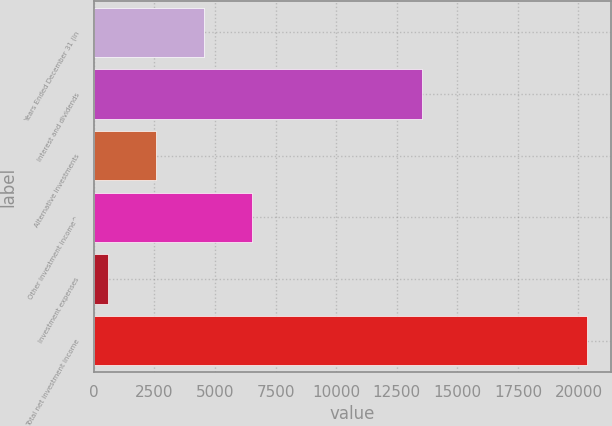Convert chart to OTSL. <chart><loc_0><loc_0><loc_500><loc_500><bar_chart><fcel>Years Ended December 31 (in<fcel>Interest and dividends<fcel>Alternative investments<fcel>Other investment income^<fcel>Investment expenses<fcel>Total net investment income<nl><fcel>4551.8<fcel>13544<fcel>2577.9<fcel>6525.7<fcel>604<fcel>20343<nl></chart> 